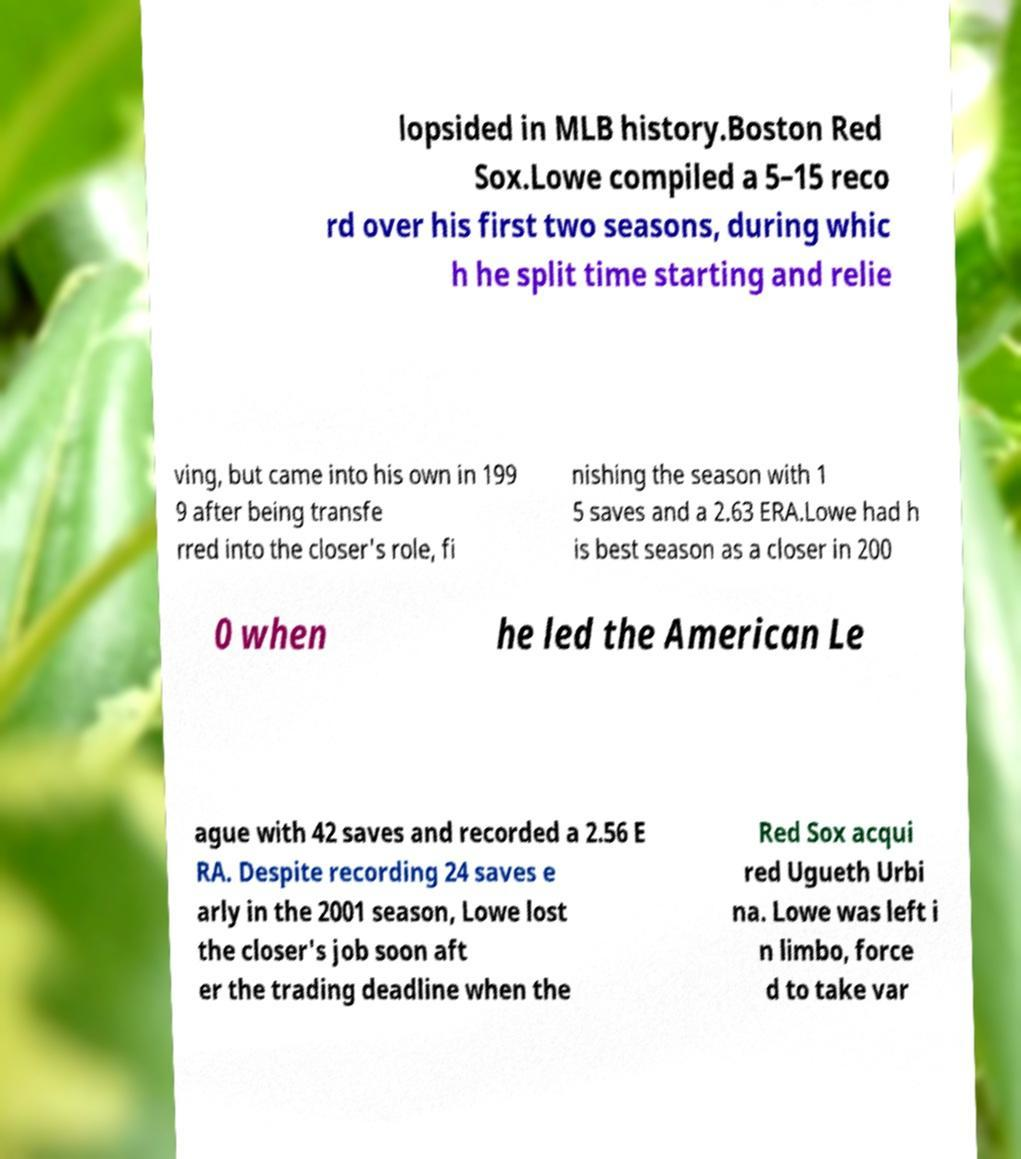For documentation purposes, I need the text within this image transcribed. Could you provide that? lopsided in MLB history.Boston Red Sox.Lowe compiled a 5–15 reco rd over his first two seasons, during whic h he split time starting and relie ving, but came into his own in 199 9 after being transfe rred into the closer's role, fi nishing the season with 1 5 saves and a 2.63 ERA.Lowe had h is best season as a closer in 200 0 when he led the American Le ague with 42 saves and recorded a 2.56 E RA. Despite recording 24 saves e arly in the 2001 season, Lowe lost the closer's job soon aft er the trading deadline when the Red Sox acqui red Ugueth Urbi na. Lowe was left i n limbo, force d to take var 